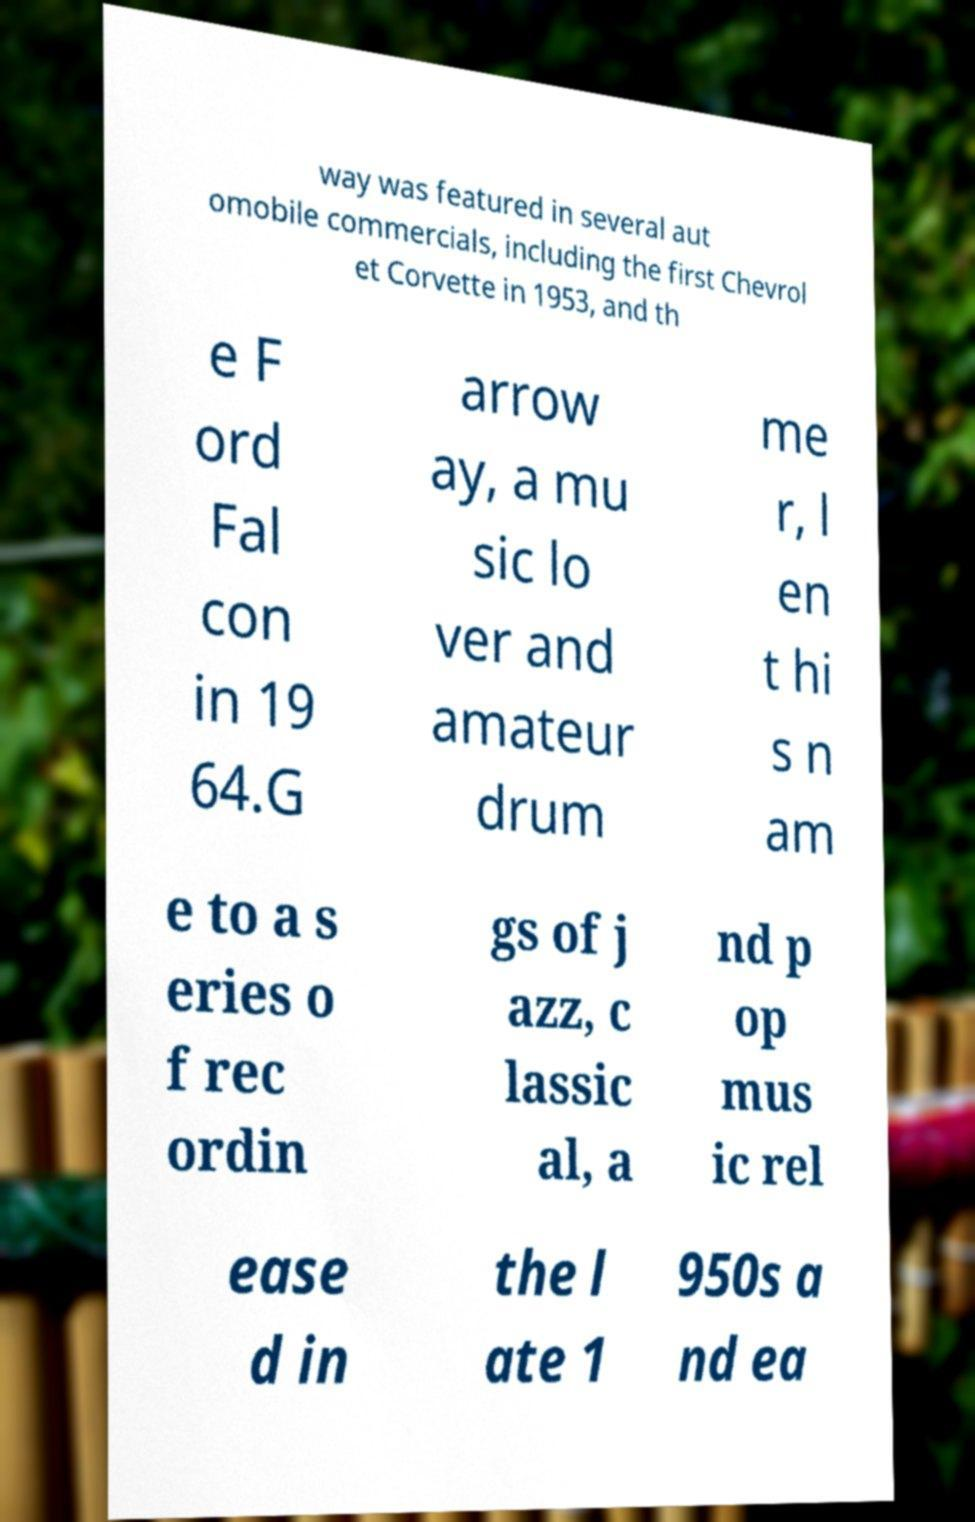Please read and relay the text visible in this image. What does it say? way was featured in several aut omobile commercials, including the first Chevrol et Corvette in 1953, and th e F ord Fal con in 19 64.G arrow ay, a mu sic lo ver and amateur drum me r, l en t hi s n am e to a s eries o f rec ordin gs of j azz, c lassic al, a nd p op mus ic rel ease d in the l ate 1 950s a nd ea 